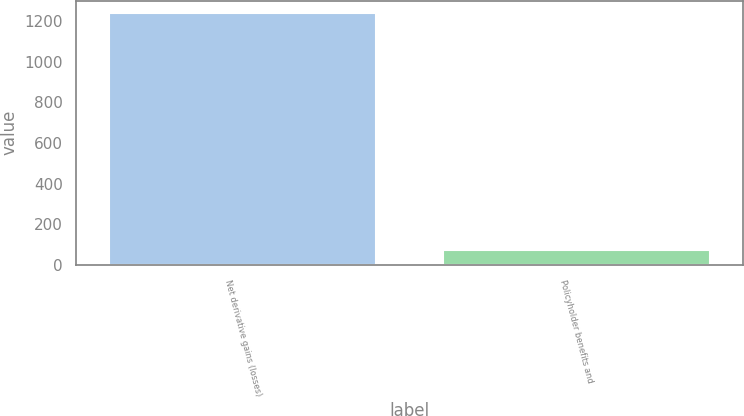<chart> <loc_0><loc_0><loc_500><loc_500><bar_chart><fcel>Net derivative gains (losses)<fcel>Policyholder benefits and<nl><fcel>1239<fcel>75<nl></chart> 